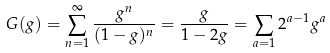<formula> <loc_0><loc_0><loc_500><loc_500>G ( g ) = \sum _ { n = 1 } ^ { \infty } \frac { g ^ { n } } { ( 1 - g ) ^ { n } } = \frac { g } { 1 - 2 g } = \sum _ { a = 1 } 2 ^ { a - 1 } g ^ { a }</formula> 